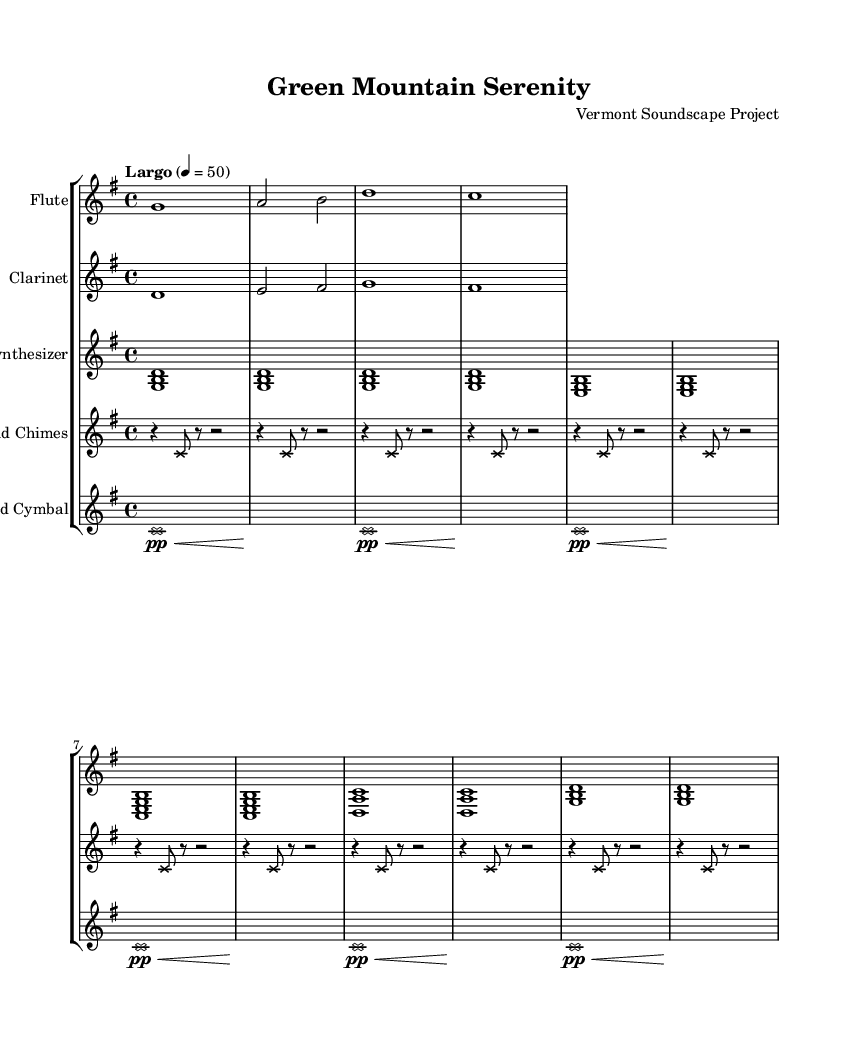What is the key signature of this music? The key signature indicates G major, which has one sharp (F#). The global staff indicates a key of G major.
Answer: G major What is the time signature of this music? The time signature is indicated at the beginning and shows a 4/4 rhythm. This means there are four beats in each measure.
Answer: 4/4 What is the tempo marking for this piece? The tempo marking is at the start of the score and is indicated as "Largo" with a metronome marking of 50. "Largo" usually indicates a slow tempo.
Answer: Largo 4 = 50 How many instruments are included in the score? The score contains five distinct instrument parts: flute, clarinet, synthesizer, wind chimes, and bowed cymbal. Each is represented on separate staves.
Answer: Five What type of scale is predominantly used by the synthesizer? The synthesizer uses a series of triads, primarily composed of the notes G, B, and D, which together form the G major chord. This is repeated throughout the score.
Answer: G major chord Which instrument has a unique notehead style? Both the wind chimes and bowed cymbal sections have a special notehead style represented by a cross shape, which distinguishes them from the other instruments.
Answer: Wind chimes and bowed cymbal What kind of mood does the piece aim to portray through its instrumentation? The piece creates a serene and tranquil mood, reflective of Vermont's natural landscapes, through the use of gentle and ambient sounds from its instrumentation.
Answer: Serene 